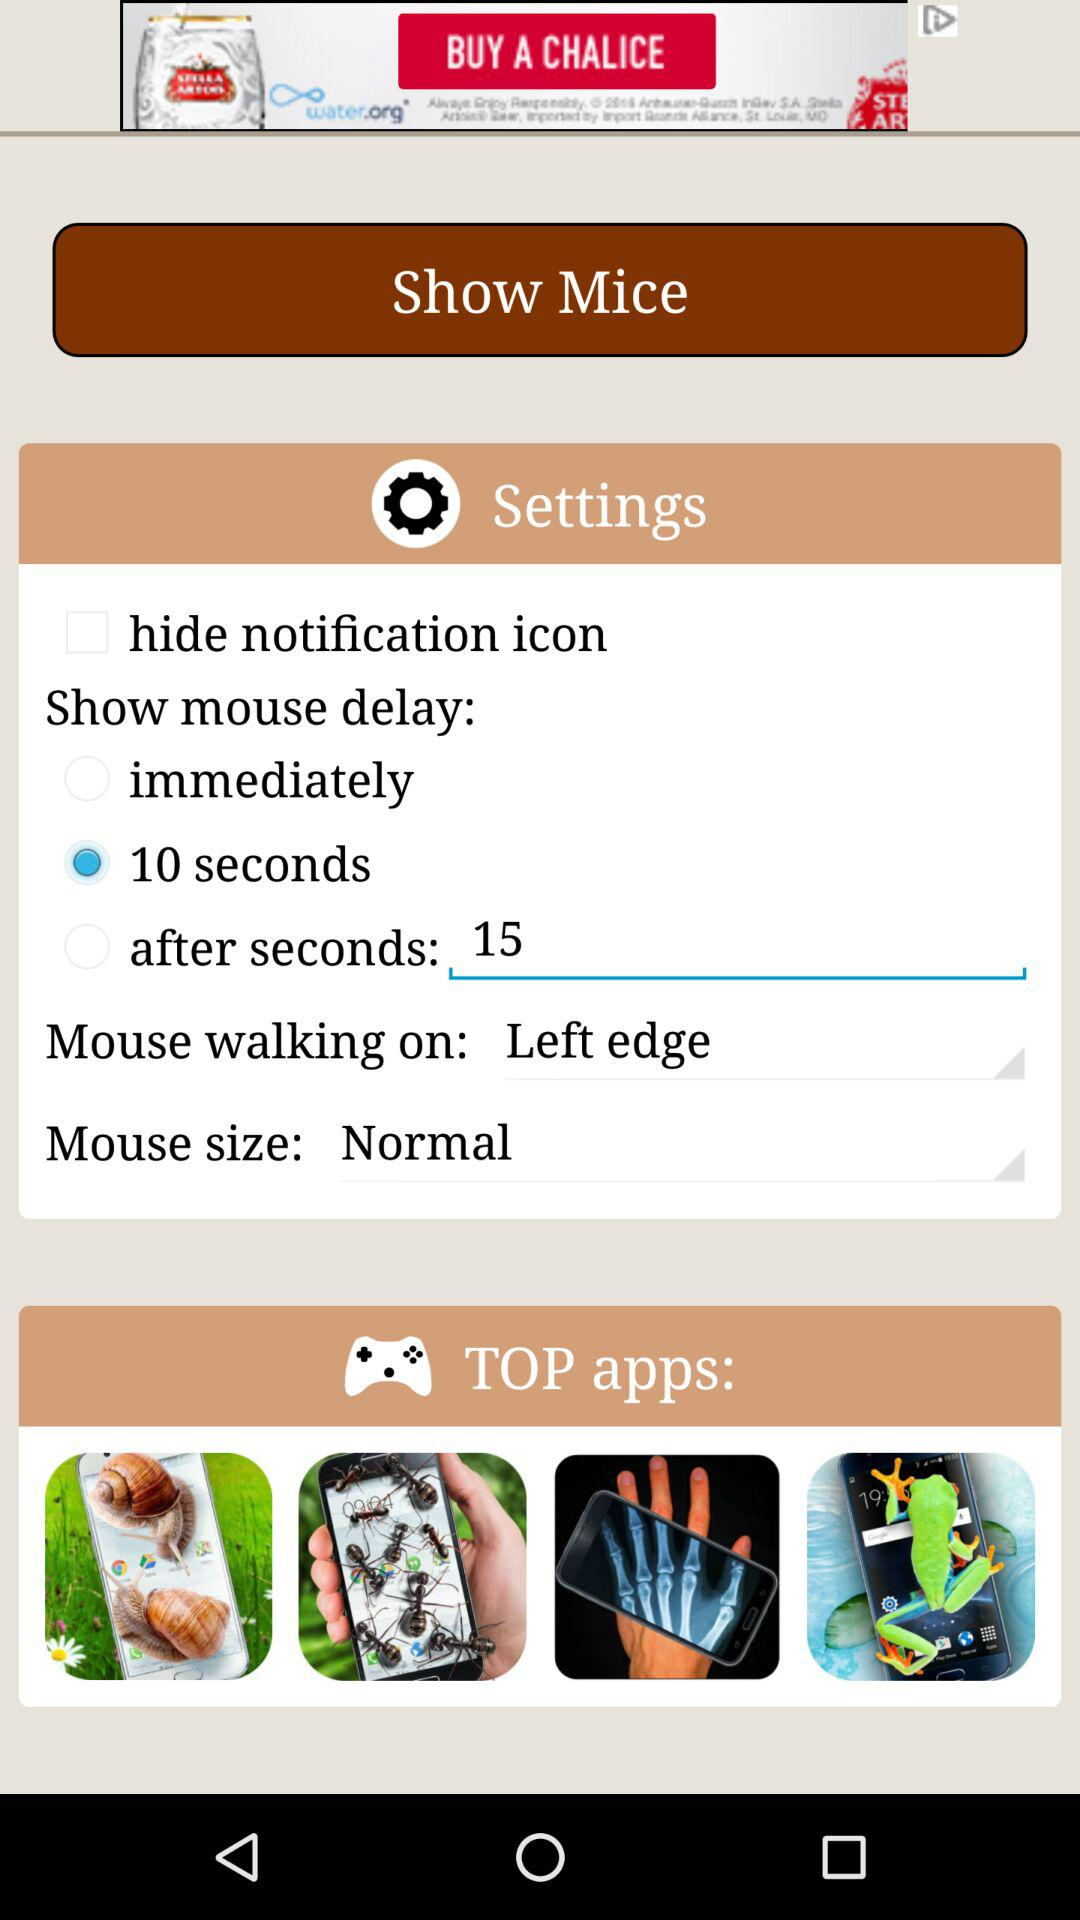What option is selected for "Show mouse delay"? The selected option for "Show mouse delay" is "10 seconds". 